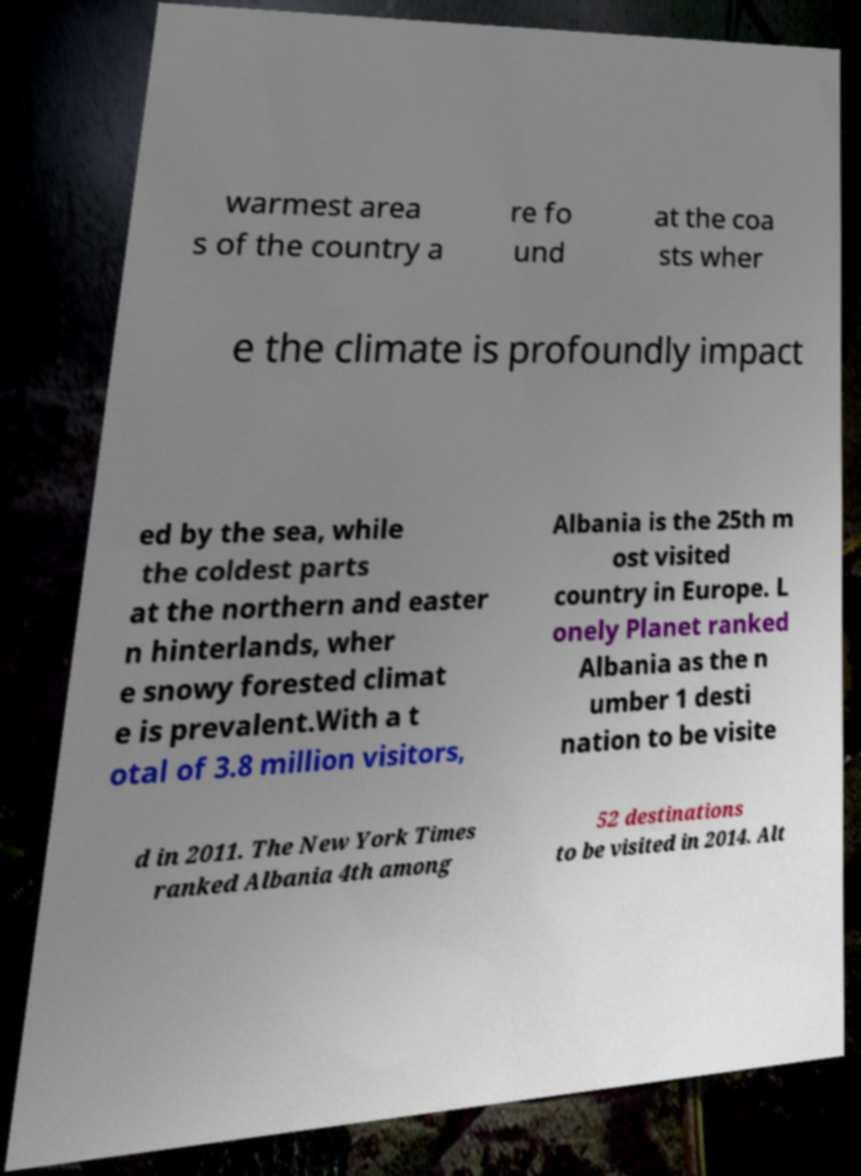Could you extract and type out the text from this image? warmest area s of the country a re fo und at the coa sts wher e the climate is profoundly impact ed by the sea, while the coldest parts at the northern and easter n hinterlands, wher e snowy forested climat e is prevalent.With a t otal of 3.8 million visitors, Albania is the 25th m ost visited country in Europe. L onely Planet ranked Albania as the n umber 1 desti nation to be visite d in 2011. The New York Times ranked Albania 4th among 52 destinations to be visited in 2014. Alt 